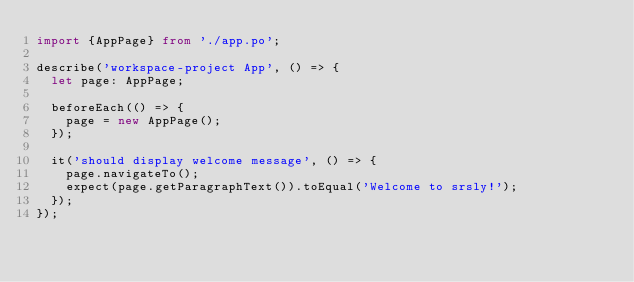Convert code to text. <code><loc_0><loc_0><loc_500><loc_500><_TypeScript_>import {AppPage} from './app.po';

describe('workspace-project App', () => {
  let page: AppPage;

  beforeEach(() => {
    page = new AppPage();
  });

  it('should display welcome message', () => {
    page.navigateTo();
    expect(page.getParagraphText()).toEqual('Welcome to srsly!');
  });
});
</code> 